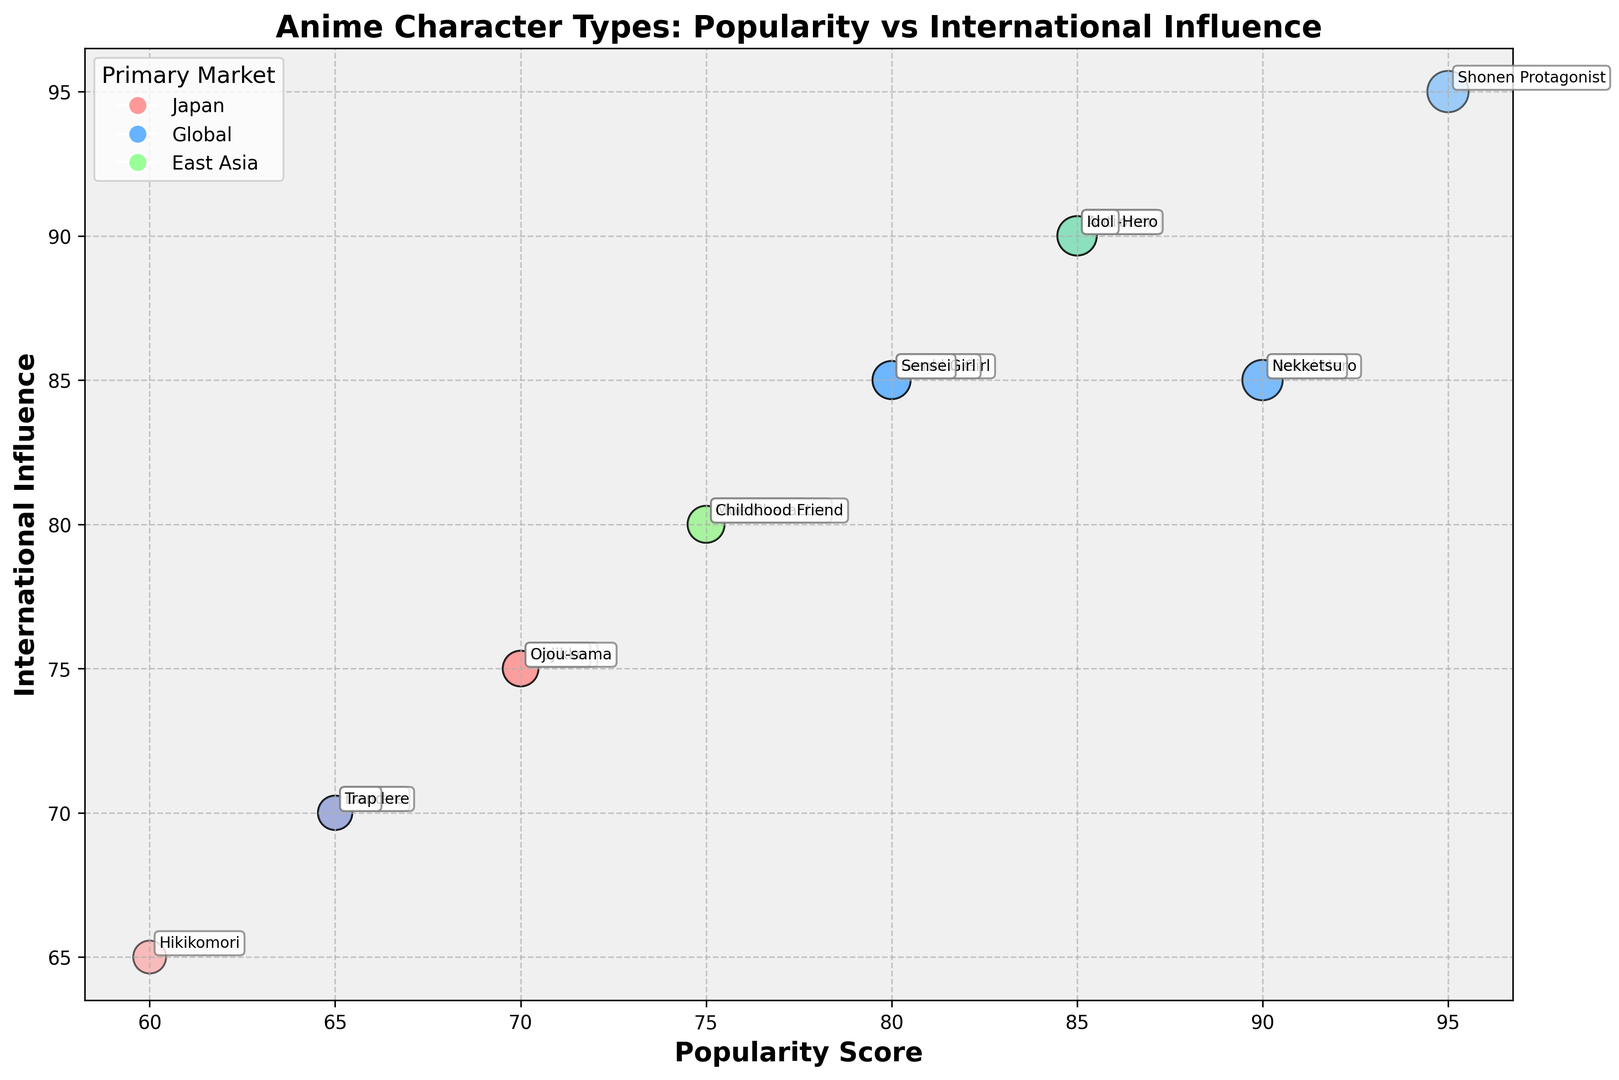Which character type has the highest Popularity Score and what is its Primary Market? The "Shonen Protagonist" has the highest Popularity Score at 95, and its Primary Market is Global.
Answer: Shonen Protagonist, Global Between "Tsundere" and "Dojikko", which character type has a higher International Influence? "Tsundere" has an International Influence score of 90, while "Dojikko" has a score of 75. Thus, "Tsundere" has a higher International Influence.
Answer: Tsundere Which two character types have the same Popularity Score and also have the same Primary Market? "Genki Girl" and "Sensei" both have a Popularity Score of 80 and their Primary Market is Global.
Answer: Genki Girl, Sensei How many character types have a Popularity Score above 85? Character types with a Popularity Score above 85 are "Shonen Protagonist" (95), "Isekai Hero" (90), "Tsundere" (85), "Bishonen" (85), "Idol" (85), "Anti-Hero" (85), and "Nekketsu" (90). There are 7 of them.
Answer: 7 What is the color representing characters whose Primary Market is Japan? By observing the color legend in the chart, the color representing characters with the Primary Market in Japan is light pink.
Answer: light pink 